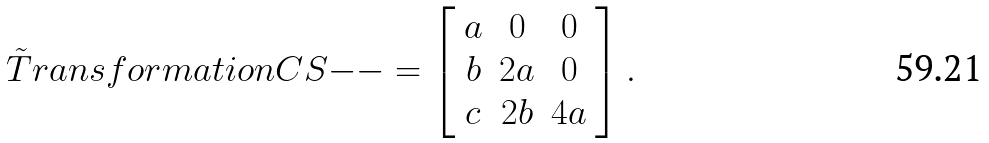<formula> <loc_0><loc_0><loc_500><loc_500>\tilde { T } r a n s f o r m a t i o n C S { - - } = \left [ \begin{array} { c c c } a & 0 & 0 \\ b & 2 a & 0 \\ c & 2 b & 4 a \end{array} \right ] .</formula> 